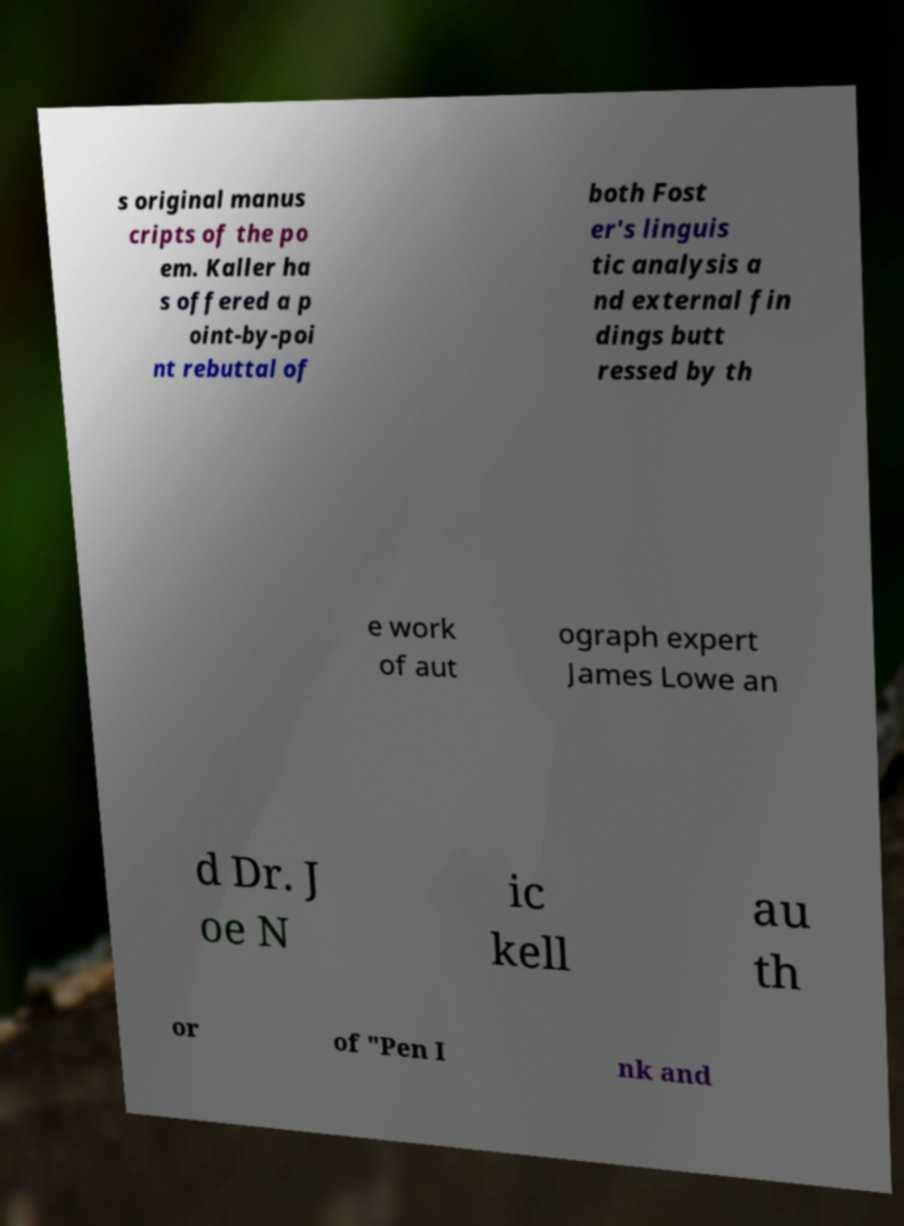Can you accurately transcribe the text from the provided image for me? s original manus cripts of the po em. Kaller ha s offered a p oint-by-poi nt rebuttal of both Fost er's linguis tic analysis a nd external fin dings butt ressed by th e work of aut ograph expert James Lowe an d Dr. J oe N ic kell au th or of "Pen I nk and 